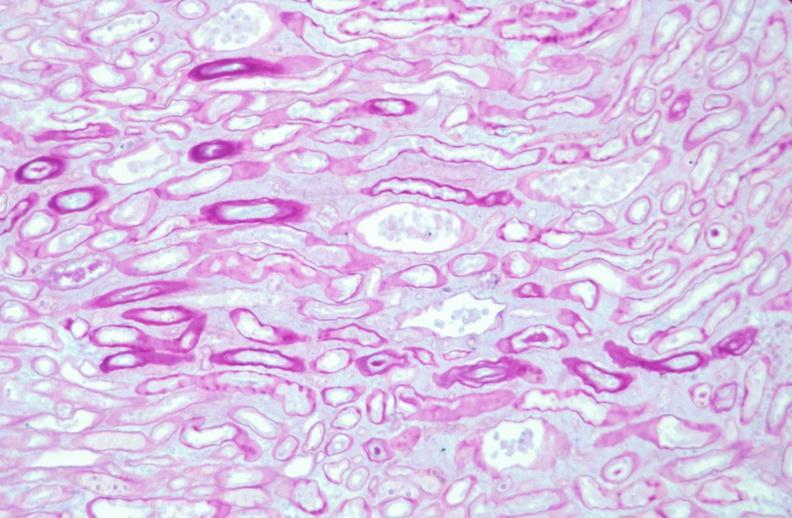where is this?
Answer the question using a single word or phrase. Urinary 